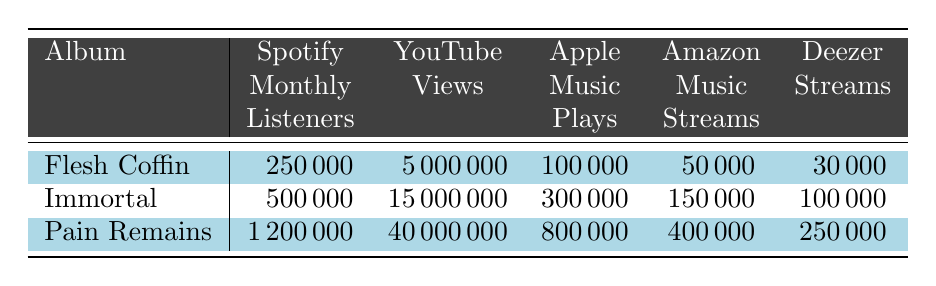What are the Spotify Monthly Listeners for "Immortal"? From the table, we can directly see that "Immortal" has 500,000 Spotify Monthly Listeners listed under that column.
Answer: 500,000 Which album has the highest number of YouTube Views? By comparing the YouTube Views for each album in the second column, "Pain Remains" has the highest number with 40,000,000 views.
Answer: Pain Remains What is the sum of the Apple Music Plays for all three albums? Adding the Apple Music Plays for each album gives: 100,000 (Flesh Coffin) + 300,000 (Immortal) + 800,000 (Pain Remains) = 1,200,000.
Answer: 1,200,000 Is the number of Amazon Music Streams for "Flesh Coffin" greater than 30,000? The table shows that "Flesh Coffin" has 50,000 Amazon Music Streams, which is indeed greater than 30,000.
Answer: Yes What is the average number of Spotify Monthly Listeners across all three albums? The total Spotify Monthly Listeners for all albums is 250,000 + 500,000 + 1,200,000 = 1,950,000. Dividing this by the number of albums (3), we get 1,950,000 / 3 = 650,000.
Answer: 650,000 Which album has the lowest Apple Music Plays? Examining the Apple Music Plays, "Flesh Coffin" has the lowest at 100,000 compared to the others: 300,000 (Immortal) and 800,000 (Pain Remains).
Answer: Flesh Coffin What is the difference in YouTube Views between "Pain Remains" and "Immortal"? To find the difference, we subtract the YouTube Views of "Immortal" from "Pain Remains": 40,000,000 - 15,000,000 = 25,000,000.
Answer: 25,000,000 Is it true that "Pain Remains" has more streams on Deezer than "Immortal"? The table shows that "Pain Remains" has 250,000 Deezer Streams and "Immortal" has 100,000. Since 250,000 > 100,000, it is true.
Answer: Yes What percentage of the total Spotify Monthly Listeners does "Flesh Coffin" represent? First, total Spotify Monthly Listeners = 250,000 + 500,000 + 1,200,000 = 1,950,000. Then, the percentage for "Flesh Coffin" is (250,000 / 1,950,000) * 100 = approximately 12.82%.
Answer: 12.82% What is the total number of streams on all platforms for the album "Immortal"? Adding the streams for all platforms: 500,000 (Spotify) + 15,000,000 (YouTube) + 300,000 (Apple) + 150,000 (Amazon) + 100,000 (Deezer) gives 15,050,000.
Answer: 15,050,000 